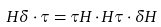<formula> <loc_0><loc_0><loc_500><loc_500>H \delta \cdot \tau = \tau H \cdot H \tau \cdot \delta H</formula> 